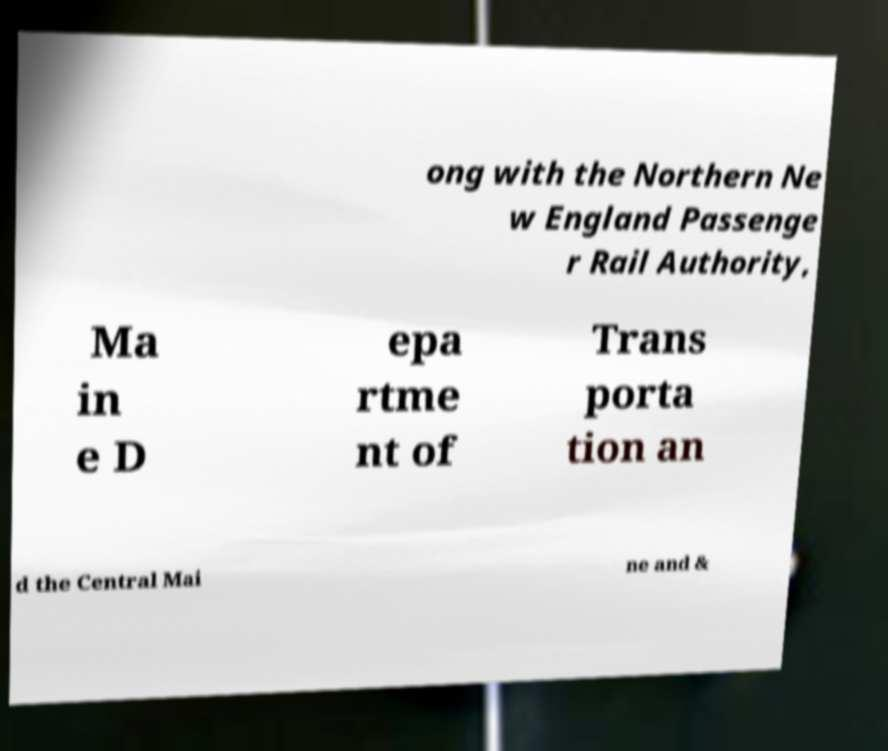For documentation purposes, I need the text within this image transcribed. Could you provide that? ong with the Northern Ne w England Passenge r Rail Authority, Ma in e D epa rtme nt of Trans porta tion an d the Central Mai ne and & 